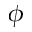<formula> <loc_0><loc_0><loc_500><loc_500>\phi</formula> 